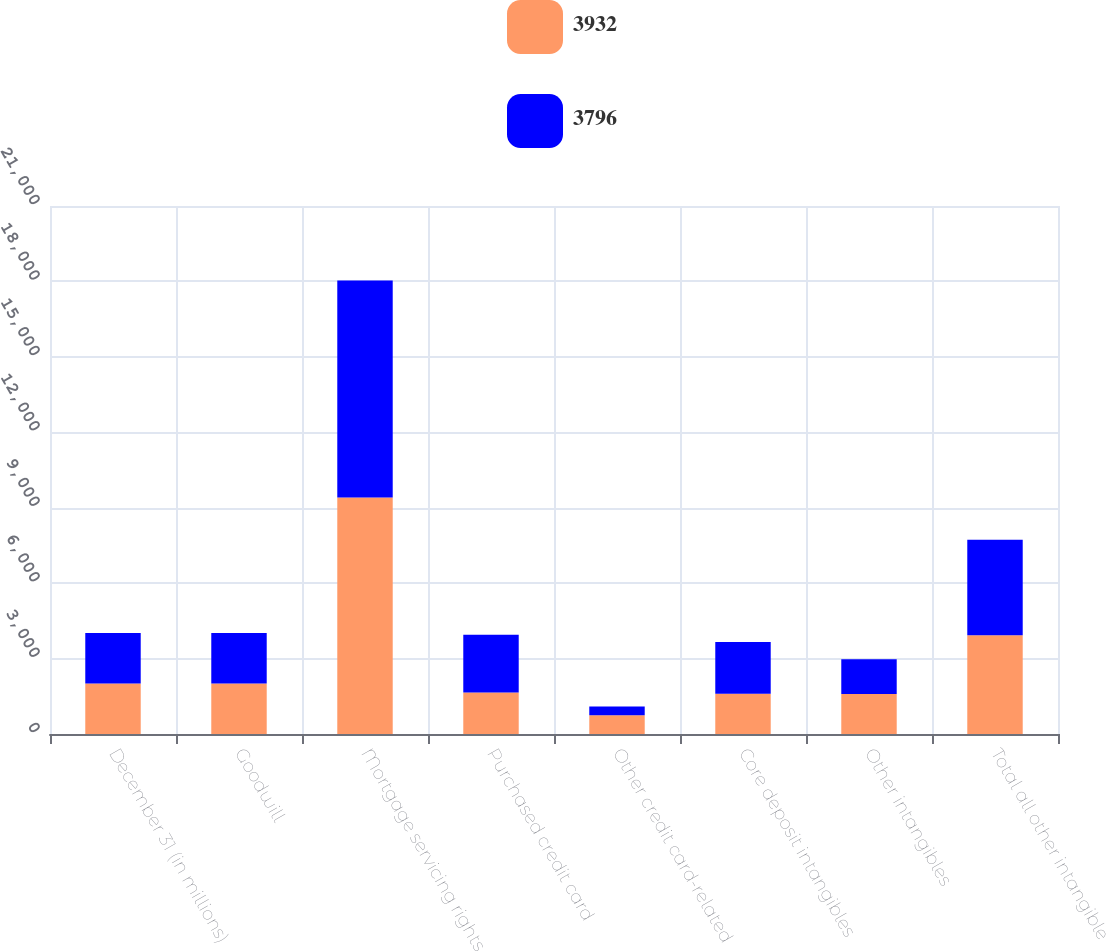Convert chart. <chart><loc_0><loc_0><loc_500><loc_500><stacked_bar_chart><ecel><fcel>December 31 (in millions)<fcel>Goodwill<fcel>Mortgage servicing rights<fcel>Purchased credit card<fcel>Other credit card-related<fcel>Core deposit intangibles<fcel>Other intangibles<fcel>Total all other intangible<nl><fcel>3932<fcel>2008<fcel>2007.5<fcel>9403<fcel>1649<fcel>743<fcel>1597<fcel>1592<fcel>3932<nl><fcel>3796<fcel>2007<fcel>2007.5<fcel>8632<fcel>2303<fcel>346<fcel>2067<fcel>1383<fcel>3796<nl></chart> 